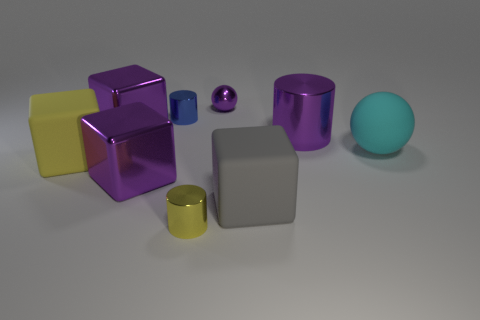What is the material of the yellow object that is the same shape as the gray matte thing? rubber 